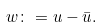<formula> <loc_0><loc_0><loc_500><loc_500>w \colon = u - \bar { u } .</formula> 